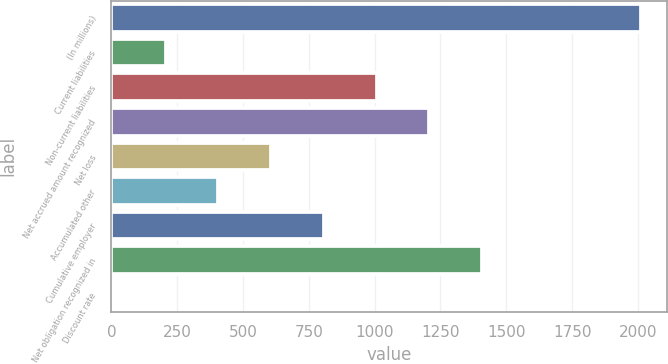Convert chart. <chart><loc_0><loc_0><loc_500><loc_500><bar_chart><fcel>(In millions)<fcel>Current liabilities<fcel>Non-current liabilities<fcel>Net accrued amount recognized<fcel>Net loss<fcel>Accumulated other<fcel>Cumulative employer<fcel>Net obligation recognized in<fcel>Discount rate<nl><fcel>2010<fcel>205.95<fcel>1007.75<fcel>1208.2<fcel>606.85<fcel>406.4<fcel>807.3<fcel>1408.65<fcel>5.5<nl></chart> 